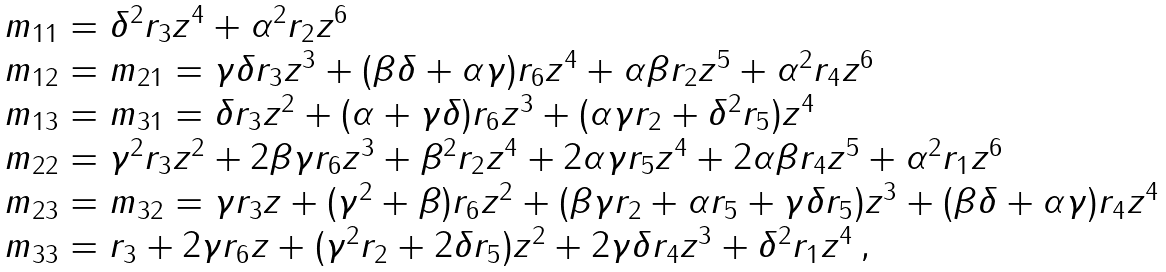Convert formula to latex. <formula><loc_0><loc_0><loc_500><loc_500>\begin{array} { l } m _ { 1 1 } = \delta ^ { 2 } r _ { 3 } z ^ { 4 } + \alpha ^ { 2 } r _ { 2 } z ^ { 6 } \\ m _ { 1 2 } = m _ { 2 1 } = \gamma \delta r _ { 3 } z ^ { 3 } + ( \beta \delta + \alpha \gamma ) r _ { 6 } z ^ { 4 } + \alpha \beta r _ { 2 } z ^ { 5 } + \alpha ^ { 2 } r _ { 4 } z ^ { 6 } \\ m _ { 1 3 } = m _ { 3 1 } = \delta r _ { 3 } z ^ { 2 } + ( \alpha + \gamma \delta ) r _ { 6 } z ^ { 3 } + ( \alpha \gamma r _ { 2 } + \delta ^ { 2 } r _ { 5 } ) z ^ { 4 } \\ m _ { 2 2 } = \gamma ^ { 2 } r _ { 3 } z ^ { 2 } + 2 \beta \gamma r _ { 6 } z ^ { 3 } + \beta ^ { 2 } r _ { 2 } z ^ { 4 } + 2 \alpha \gamma r _ { 5 } z ^ { 4 } + 2 \alpha \beta r _ { 4 } z ^ { 5 } + \alpha ^ { 2 } r _ { 1 } z ^ { 6 } \\ m _ { 2 3 } = m _ { 3 2 } = \gamma r _ { 3 } z + ( \gamma ^ { 2 } + \beta ) r _ { 6 } z ^ { 2 } + ( \beta \gamma r _ { 2 } + \alpha r _ { 5 } + \gamma \delta r _ { 5 } ) z ^ { 3 } + ( \beta \delta + \alpha \gamma ) r _ { 4 } z ^ { 4 } \\ m _ { 3 3 } = r _ { 3 } + 2 \gamma r _ { 6 } z + ( \gamma ^ { 2 } r _ { 2 } + 2 \delta r _ { 5 } ) z ^ { 2 } + 2 \gamma \delta r _ { 4 } z ^ { 3 } + \delta ^ { 2 } r _ { 1 } z ^ { 4 } \, , \end{array}</formula> 